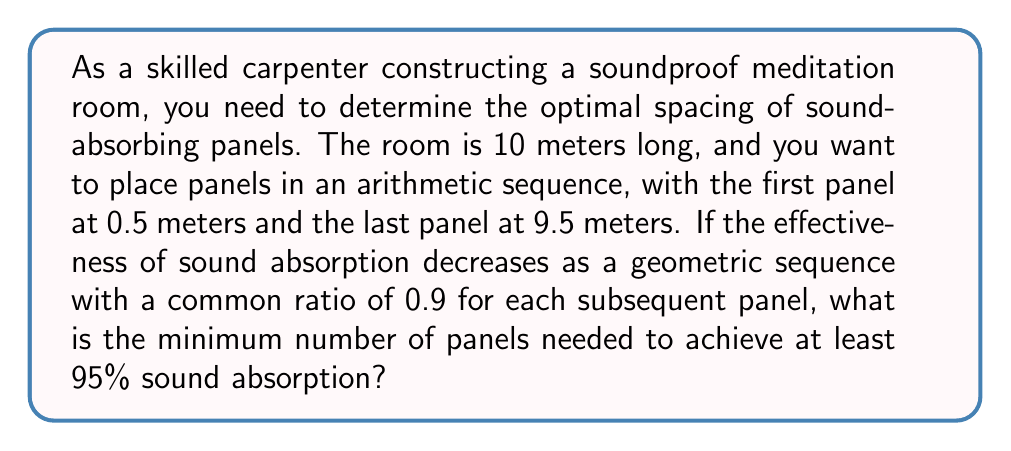Provide a solution to this math problem. Let's approach this step-by-step:

1) First, let's define our arithmetic sequence for panel positions:
   $a_1 = 0.5$, $a_n = 9.5$, where $n$ is the number of panels.
   The common difference $d$ can be found using:
   $$d = \frac{a_n - a_1}{n-1} = \frac{9 - 0}{n-1} = \frac{9}{n-1}$$

2) Now, let's consider the geometric sequence for sound absorption effectiveness:
   First panel: 1
   Second panel: 0.9
   Third panel: 0.81
   ...and so on.

3) The sum of this geometric sequence represents the total sound absorption. We need this sum to be at least 0.95 (95%):

   $$S_n = \frac{1-0.9^n}{1-0.9} \geq 0.95$$

4) Solving this inequality:
   $$1-0.9^n \geq 0.95 \cdot 0.1$$
   $$1-0.9^n \geq 0.095$$
   $$-0.9^n \geq -0.905$$
   $$0.9^n \leq 0.905$$

5) Taking logarithms of both sides:
   $$n \log 0.9 \leq \log 0.905$$
   $$n \geq \frac{\log 0.905}{\log 0.9} \approx 28.5$$

6) Since $n$ must be an integer, we round up to 29.

Therefore, a minimum of 29 panels are needed to achieve at least 95% sound absorption.
Answer: 29 panels 